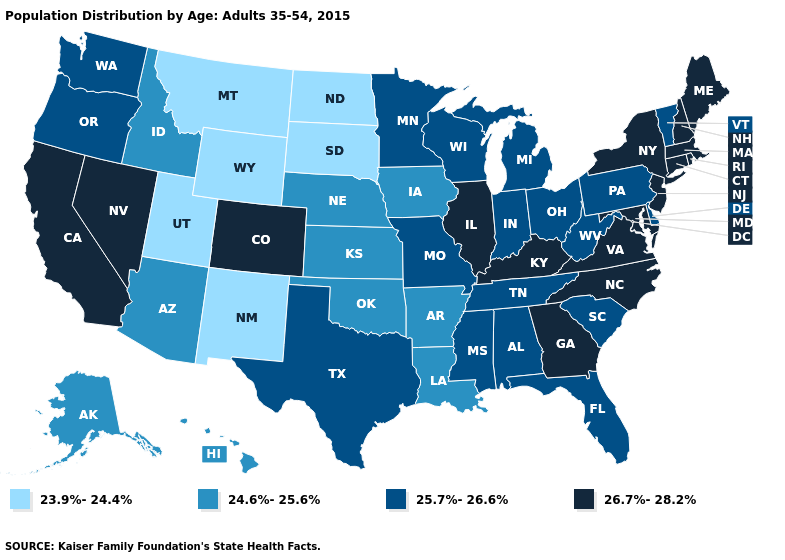What is the highest value in states that border Wyoming?
Write a very short answer. 26.7%-28.2%. How many symbols are there in the legend?
Keep it brief. 4. Does the map have missing data?
Be succinct. No. Which states have the lowest value in the Northeast?
Quick response, please. Pennsylvania, Vermont. Name the states that have a value in the range 23.9%-24.4%?
Give a very brief answer. Montana, New Mexico, North Dakota, South Dakota, Utah, Wyoming. Among the states that border Maryland , does Pennsylvania have the lowest value?
Write a very short answer. Yes. Does Hawaii have a lower value than Kentucky?
Answer briefly. Yes. Which states have the lowest value in the West?
Answer briefly. Montana, New Mexico, Utah, Wyoming. What is the lowest value in the West?
Give a very brief answer. 23.9%-24.4%. Among the states that border Wyoming , which have the highest value?
Short answer required. Colorado. Name the states that have a value in the range 26.7%-28.2%?
Be succinct. California, Colorado, Connecticut, Georgia, Illinois, Kentucky, Maine, Maryland, Massachusetts, Nevada, New Hampshire, New Jersey, New York, North Carolina, Rhode Island, Virginia. What is the lowest value in the USA?
Give a very brief answer. 23.9%-24.4%. Name the states that have a value in the range 24.6%-25.6%?
Write a very short answer. Alaska, Arizona, Arkansas, Hawaii, Idaho, Iowa, Kansas, Louisiana, Nebraska, Oklahoma. Among the states that border North Dakota , which have the lowest value?
Be succinct. Montana, South Dakota. Among the states that border Missouri , does Illinois have the highest value?
Be succinct. Yes. 